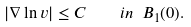<formula> <loc_0><loc_0><loc_500><loc_500>| \nabla \ln v | \leq C \quad i n \ B _ { 1 } ( 0 ) .</formula> 